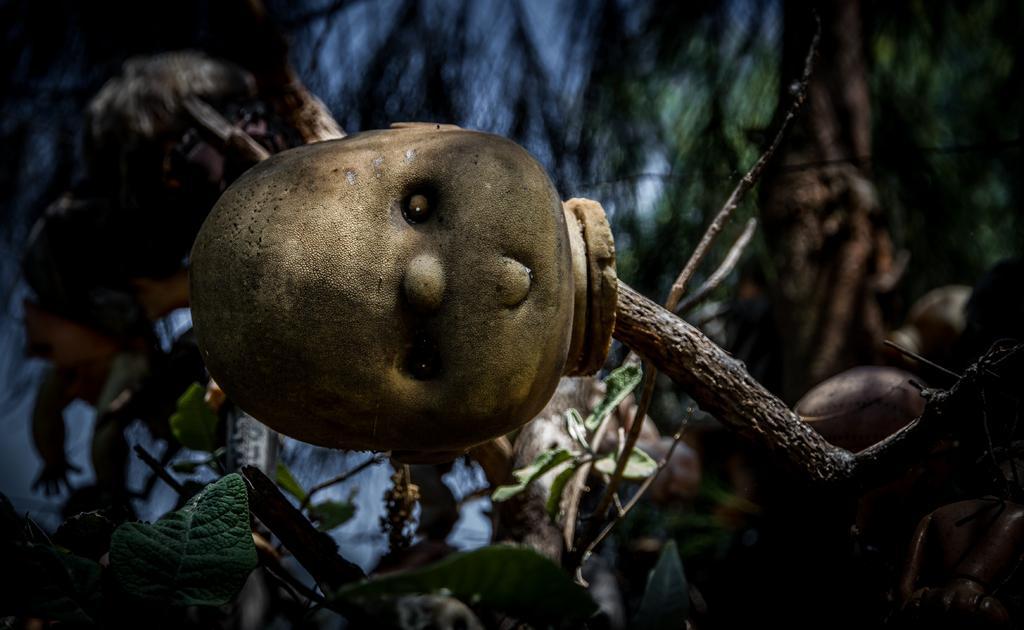Could you give a brief overview of what you see in this image? In this image we can see branches with leaves. Also we can see head of a toy. In the background it is blurry and we can see toys like objects. 